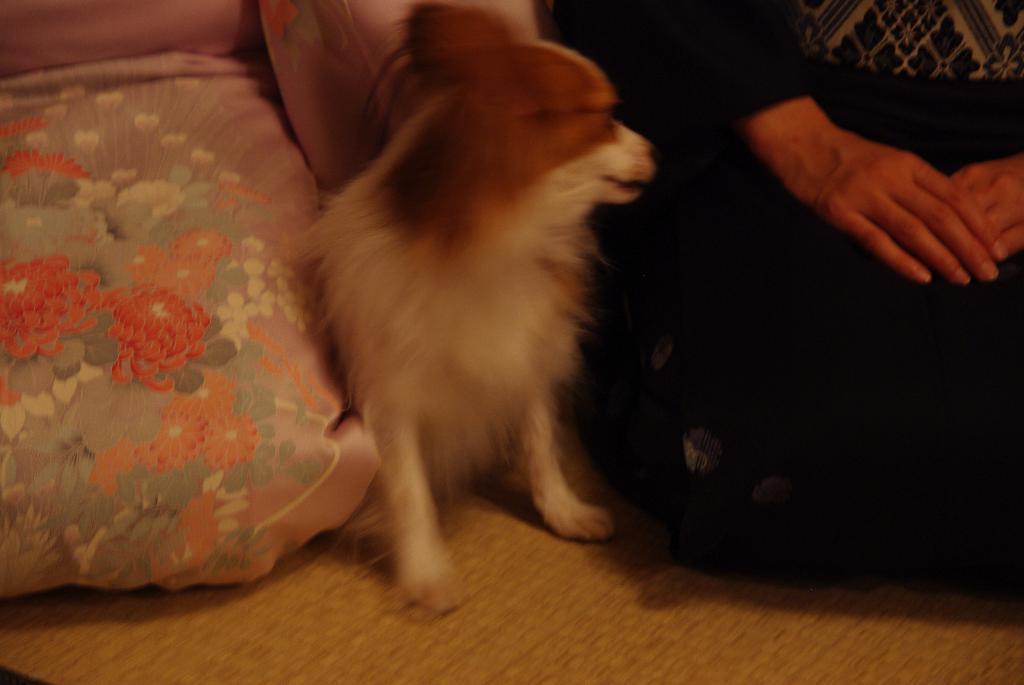How would you summarize this image in a sentence or two? In the middle it is a dog which is in white and brown color. On the right side there are human hands. 